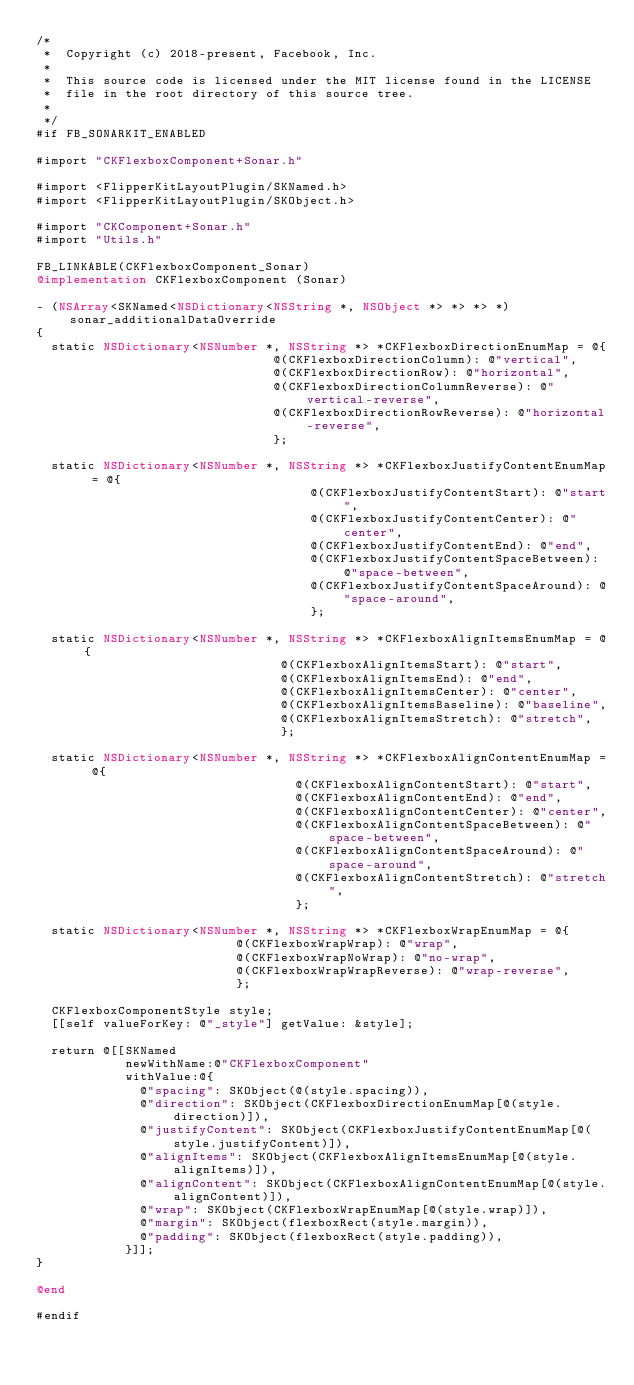Convert code to text. <code><loc_0><loc_0><loc_500><loc_500><_ObjectiveC_>/*
 *  Copyright (c) 2018-present, Facebook, Inc.
 *
 *  This source code is licensed under the MIT license found in the LICENSE
 *  file in the root directory of this source tree.
 *
 */
#if FB_SONARKIT_ENABLED

#import "CKFlexboxComponent+Sonar.h"

#import <FlipperKitLayoutPlugin/SKNamed.h>
#import <FlipperKitLayoutPlugin/SKObject.h>

#import "CKComponent+Sonar.h"
#import "Utils.h"

FB_LINKABLE(CKFlexboxComponent_Sonar)
@implementation CKFlexboxComponent (Sonar)

- (NSArray<SKNamed<NSDictionary<NSString *, NSObject *> *> *> *)sonar_additionalDataOverride
{
  static NSDictionary<NSNumber *, NSString *> *CKFlexboxDirectionEnumMap = @{
                                @(CKFlexboxDirectionColumn): @"vertical",
                                @(CKFlexboxDirectionRow): @"horizontal",
                                @(CKFlexboxDirectionColumnReverse): @"vertical-reverse",
                                @(CKFlexboxDirectionRowReverse): @"horizontal-reverse",
                                };

  static NSDictionary<NSNumber *, NSString *> *CKFlexboxJustifyContentEnumMap = @{
                                     @(CKFlexboxJustifyContentStart): @"start",
                                     @(CKFlexboxJustifyContentCenter): @"center",
                                     @(CKFlexboxJustifyContentEnd): @"end",
                                     @(CKFlexboxJustifyContentSpaceBetween): @"space-between",
                                     @(CKFlexboxJustifyContentSpaceAround): @"space-around",
                                     };

  static NSDictionary<NSNumber *, NSString *> *CKFlexboxAlignItemsEnumMap = @{
                                 @(CKFlexboxAlignItemsStart): @"start",
                                 @(CKFlexboxAlignItemsEnd): @"end",
                                 @(CKFlexboxAlignItemsCenter): @"center",
                                 @(CKFlexboxAlignItemsBaseline): @"baseline",
                                 @(CKFlexboxAlignItemsStretch): @"stretch",
                                 };

  static NSDictionary<NSNumber *, NSString *> *CKFlexboxAlignContentEnumMap = @{
                                   @(CKFlexboxAlignContentStart): @"start",
                                   @(CKFlexboxAlignContentEnd): @"end",
                                   @(CKFlexboxAlignContentCenter): @"center",
                                   @(CKFlexboxAlignContentSpaceBetween): @"space-between",
                                   @(CKFlexboxAlignContentSpaceAround): @"space-around",
                                   @(CKFlexboxAlignContentStretch): @"stretch",
                                   };

  static NSDictionary<NSNumber *, NSString *> *CKFlexboxWrapEnumMap = @{
                           @(CKFlexboxWrapWrap): @"wrap",
                           @(CKFlexboxWrapNoWrap): @"no-wrap",
                           @(CKFlexboxWrapWrapReverse): @"wrap-reverse",
                           };

  CKFlexboxComponentStyle style;
  [[self valueForKey: @"_style"] getValue: &style];

  return @[[SKNamed
            newWithName:@"CKFlexboxComponent"
            withValue:@{
              @"spacing": SKObject(@(style.spacing)),
              @"direction": SKObject(CKFlexboxDirectionEnumMap[@(style.direction)]),
              @"justifyContent": SKObject(CKFlexboxJustifyContentEnumMap[@(style.justifyContent)]),
              @"alignItems": SKObject(CKFlexboxAlignItemsEnumMap[@(style.alignItems)]),
              @"alignContent": SKObject(CKFlexboxAlignContentEnumMap[@(style.alignContent)]),
              @"wrap": SKObject(CKFlexboxWrapEnumMap[@(style.wrap)]),
              @"margin": SKObject(flexboxRect(style.margin)),
              @"padding": SKObject(flexboxRect(style.padding)),
            }]];
}

@end

#endif
</code> 